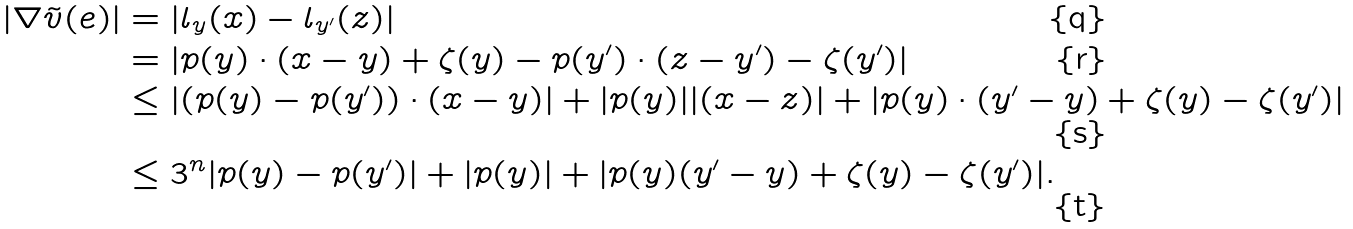Convert formula to latex. <formula><loc_0><loc_0><loc_500><loc_500>| \nabla \tilde { v } ( e ) | & = | l _ { y } ( x ) - l _ { y ^ { \prime } } ( z ) | \\ & = | p ( y ) \cdot ( x - y ) + \zeta ( y ) - p ( y ^ { \prime } ) \cdot ( z - y ^ { \prime } ) - \zeta ( y ^ { \prime } ) | \\ & \leq | ( p ( y ) - p ( y ^ { \prime } ) ) \cdot ( x - y ) | + | p ( y ) | | ( x - z ) | + | p ( y ) \cdot ( y ^ { \prime } - y ) + \zeta ( y ) - \zeta ( y ^ { \prime } ) | \\ & \leq 3 ^ { n } | p ( y ) - p ( y ^ { \prime } ) | + | p ( y ) | + | p ( y ) ( y ^ { \prime } - y ) + \zeta ( y ) - \zeta ( y ^ { \prime } ) | .</formula> 